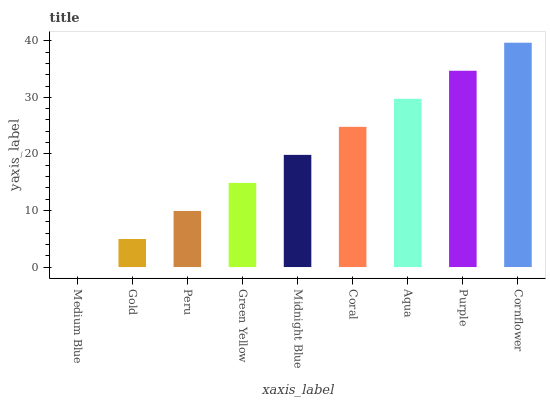Is Medium Blue the minimum?
Answer yes or no. Yes. Is Cornflower the maximum?
Answer yes or no. Yes. Is Gold the minimum?
Answer yes or no. No. Is Gold the maximum?
Answer yes or no. No. Is Gold greater than Medium Blue?
Answer yes or no. Yes. Is Medium Blue less than Gold?
Answer yes or no. Yes. Is Medium Blue greater than Gold?
Answer yes or no. No. Is Gold less than Medium Blue?
Answer yes or no. No. Is Midnight Blue the high median?
Answer yes or no. Yes. Is Midnight Blue the low median?
Answer yes or no. Yes. Is Cornflower the high median?
Answer yes or no. No. Is Cornflower the low median?
Answer yes or no. No. 